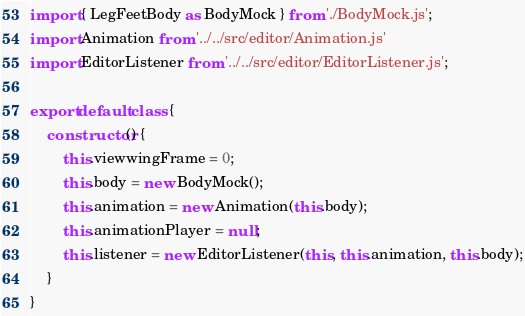Convert code to text. <code><loc_0><loc_0><loc_500><loc_500><_JavaScript_>import { LegFeetBody as BodyMock } from './BodyMock.js';
import Animation from '../../src/editor/Animation.js'
import EditorListener from '../../src/editor/EditorListener.js';

export default class {
    constructor() {
        this.viewwingFrame = 0;
        this.body = new BodyMock();
        this.animation = new Animation(this.body);
        this.animationPlayer = null;
        this.listener = new EditorListener(this, this.animation, this.body);
    }
}
</code> 